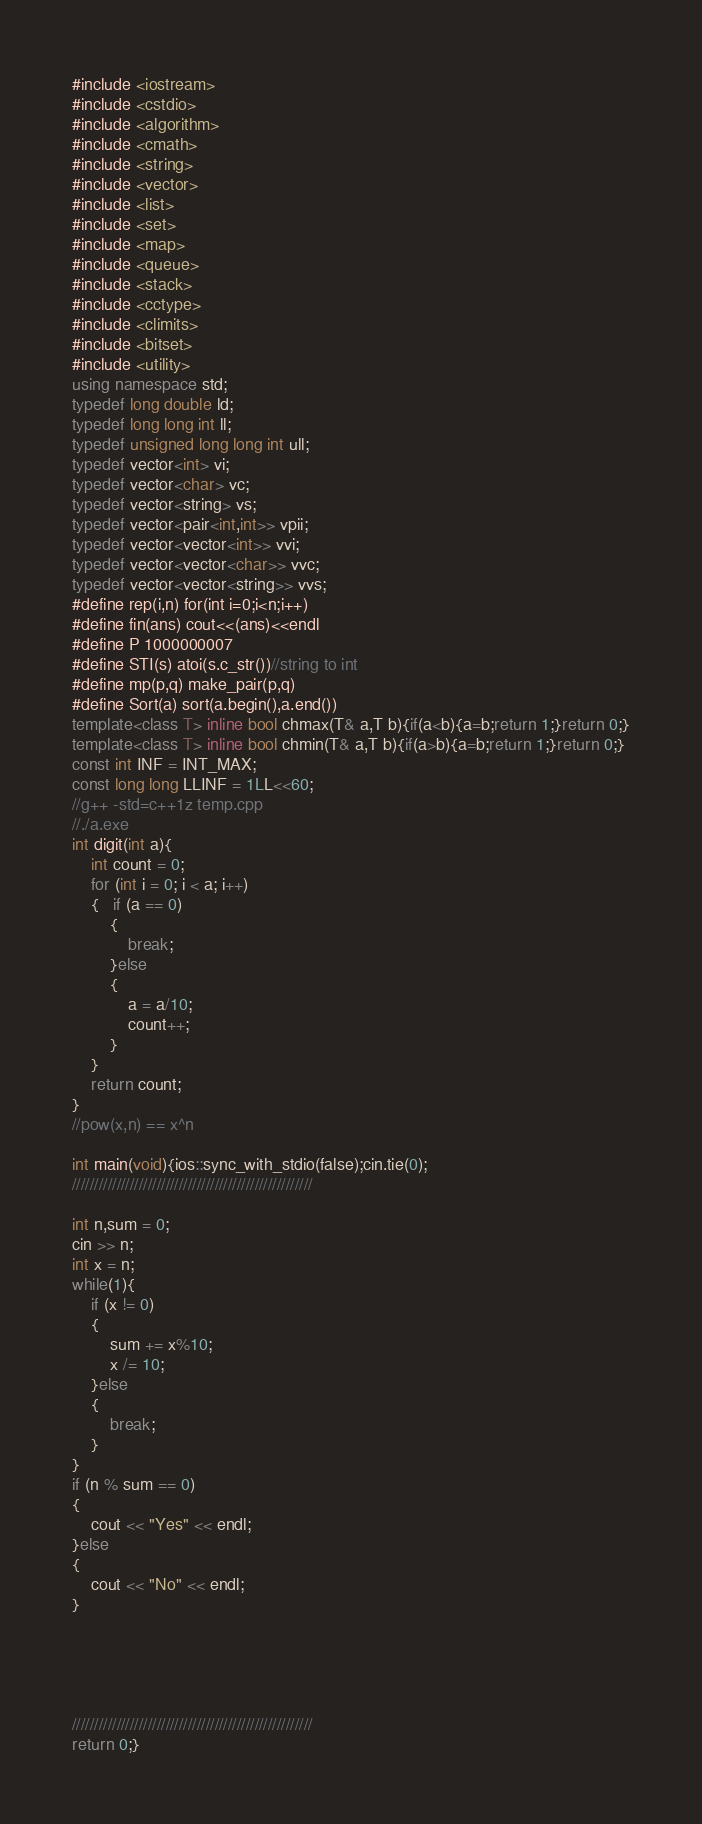Convert code to text. <code><loc_0><loc_0><loc_500><loc_500><_C++_>#include <iostream>
#include <cstdio>
#include <algorithm>
#include <cmath>
#include <string>
#include <vector>
#include <list>
#include <set>
#include <map>
#include <queue>
#include <stack>
#include <cctype>
#include <climits>
#include <bitset>
#include <utility>
using namespace std;
typedef long double ld;
typedef long long int ll;
typedef unsigned long long int ull;
typedef vector<int> vi;
typedef vector<char> vc;
typedef vector<string> vs;
typedef vector<pair<int,int>> vpii;
typedef vector<vector<int>> vvi;
typedef vector<vector<char>> vvc;
typedef vector<vector<string>> vvs;
#define rep(i,n) for(int i=0;i<n;i++)
#define fin(ans) cout<<(ans)<<endl
#define P 1000000007
#define STI(s) atoi(s.c_str())//string to int
#define mp(p,q) make_pair(p,q)
#define Sort(a) sort(a.begin(),a.end())
template<class T> inline bool chmax(T& a,T b){if(a<b){a=b;return 1;}return 0;}
template<class T> inline bool chmin(T& a,T b){if(a>b){a=b;return 1;}return 0;}
const int INF = INT_MAX;
const long long LLINF = 1LL<<60;
//g++ -std=c++1z temp.cpp
//./a.exe
int digit(int a){
    int count = 0;
    for (int i = 0; i < a; i++)
    {   if (a == 0)
        {
            break;
        }else
        {
            a = a/10;
            count++;
        }     
    }
    return count;
}
//pow(x,n) == x^n

int main(void){ios::sync_with_stdio(false);cin.tie(0);
//////////////////////////////////////////////////////

int n,sum = 0;
cin >> n;
int x = n;
while(1){
    if (x != 0)
    {
        sum += x%10;
        x /= 10;
    }else
    {
        break;
    }
}
if (n % sum == 0)
{
    cout << "Yes" << endl;
}else
{
    cout << "No" << endl;
}





//////////////////////////////////////////////////////
return 0;}</code> 